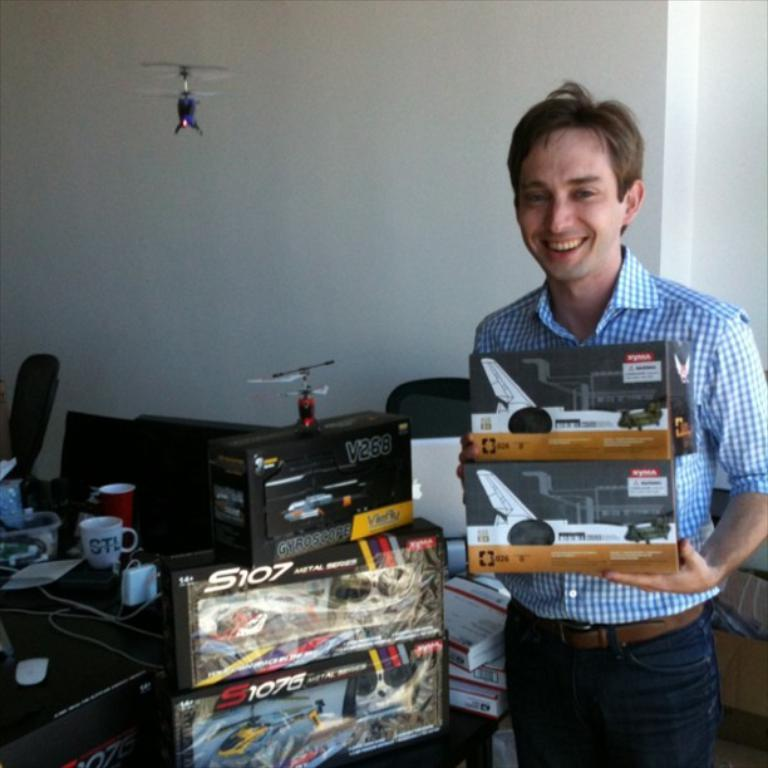<image>
Summarize the visual content of the image. a man holding two planes next to a box of S107 plane 